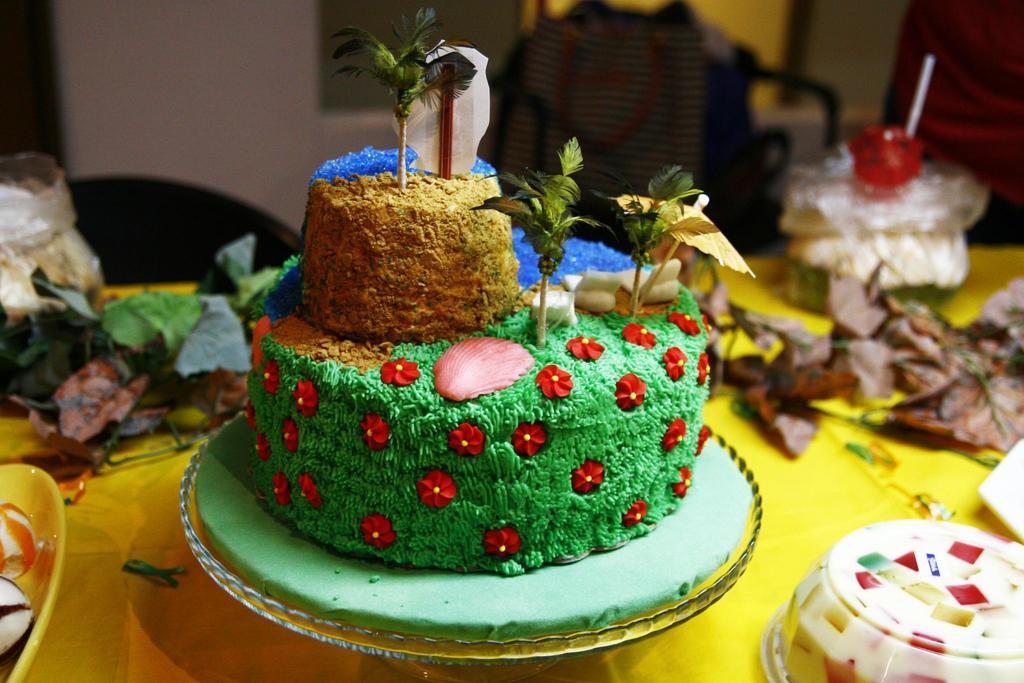Could you give a brief overview of what you see in this image? In this image, we can see desserts and there are decor items and bowls and some other objects on the table. In the background, there is a cloth, a wall and a person. 